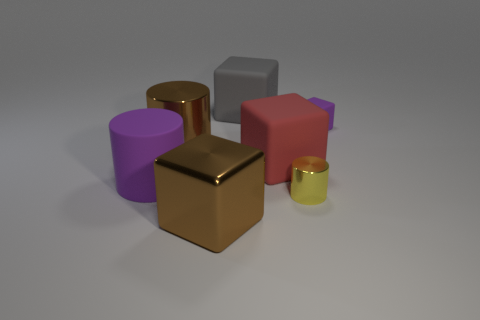Subtract all yellow cylinders. Subtract all yellow blocks. How many cylinders are left? 2 Subtract all gray spheres. How many gray blocks are left? 1 Add 1 browns. How many grays exist? 0 Subtract all purple cylinders. Subtract all gray blocks. How many objects are left? 5 Add 3 brown shiny cylinders. How many brown shiny cylinders are left? 4 Add 4 rubber cylinders. How many rubber cylinders exist? 5 Add 3 cubes. How many objects exist? 10 Subtract all brown cubes. How many cubes are left? 3 Subtract all brown metal cylinders. How many cylinders are left? 2 Subtract 0 gray cylinders. How many objects are left? 7 